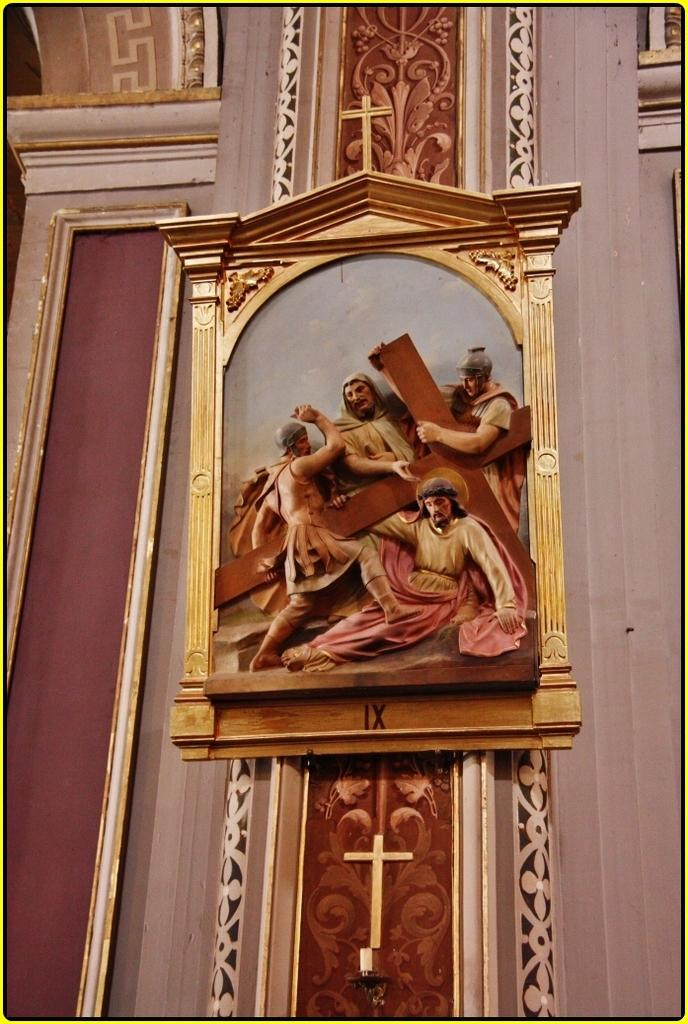What is present on the wall in the image? There is a frame placed on the wall. Are there any other features on the wall besides the frame? Yes, there are carvings on the wall. Can you describe the frame in the image? Unfortunately, the facts provided do not give enough information to describe the frame in detail. What type of drug is the lawyer using in the image? There is no lawyer or drug present in the image. What is the purpose of the hydrant in the image? There is no hydrant present in the image. 